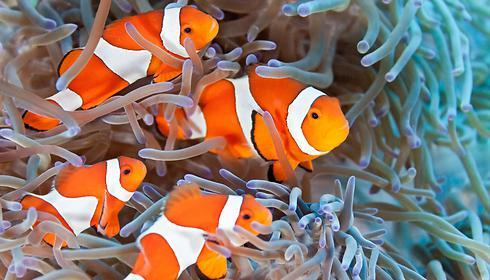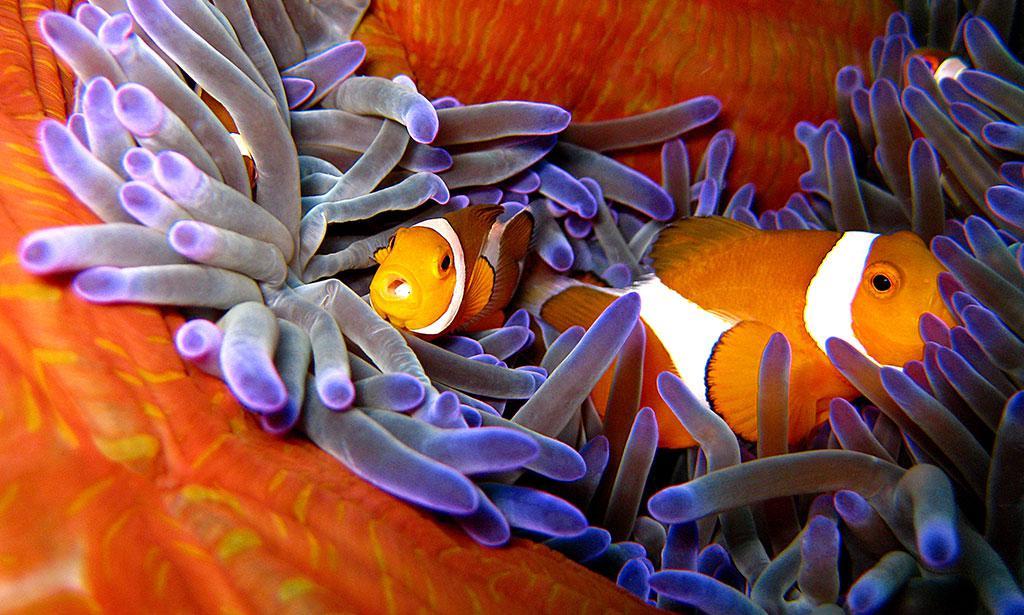The first image is the image on the left, the second image is the image on the right. For the images shown, is this caption "Each image features clownfish swimming in front of anemone tendrils, and no image contains more than four clownfish." true? Answer yes or no. Yes. 